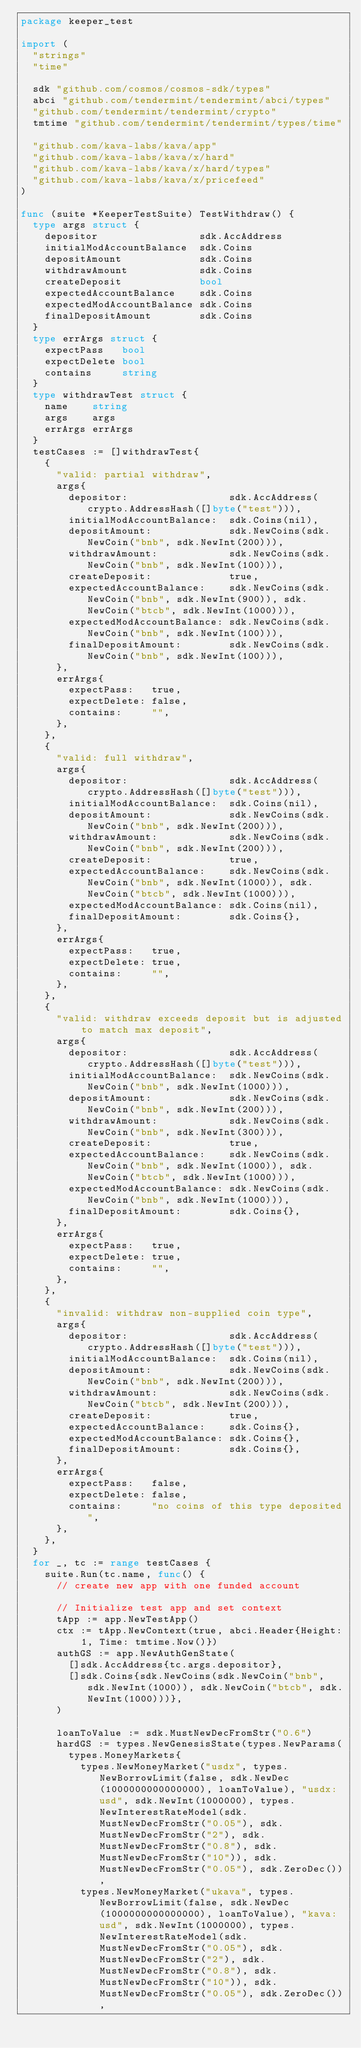Convert code to text. <code><loc_0><loc_0><loc_500><loc_500><_Go_>package keeper_test

import (
	"strings"
	"time"

	sdk "github.com/cosmos/cosmos-sdk/types"
	abci "github.com/tendermint/tendermint/abci/types"
	"github.com/tendermint/tendermint/crypto"
	tmtime "github.com/tendermint/tendermint/types/time"

	"github.com/kava-labs/kava/app"
	"github.com/kava-labs/kava/x/hard"
	"github.com/kava-labs/kava/x/hard/types"
	"github.com/kava-labs/kava/x/pricefeed"
)

func (suite *KeeperTestSuite) TestWithdraw() {
	type args struct {
		depositor                 sdk.AccAddress
		initialModAccountBalance  sdk.Coins
		depositAmount             sdk.Coins
		withdrawAmount            sdk.Coins
		createDeposit             bool
		expectedAccountBalance    sdk.Coins
		expectedModAccountBalance sdk.Coins
		finalDepositAmount        sdk.Coins
	}
	type errArgs struct {
		expectPass   bool
		expectDelete bool
		contains     string
	}
	type withdrawTest struct {
		name    string
		args    args
		errArgs errArgs
	}
	testCases := []withdrawTest{
		{
			"valid: partial withdraw",
			args{
				depositor:                 sdk.AccAddress(crypto.AddressHash([]byte("test"))),
				initialModAccountBalance:  sdk.Coins(nil),
				depositAmount:             sdk.NewCoins(sdk.NewCoin("bnb", sdk.NewInt(200))),
				withdrawAmount:            sdk.NewCoins(sdk.NewCoin("bnb", sdk.NewInt(100))),
				createDeposit:             true,
				expectedAccountBalance:    sdk.NewCoins(sdk.NewCoin("bnb", sdk.NewInt(900)), sdk.NewCoin("btcb", sdk.NewInt(1000))),
				expectedModAccountBalance: sdk.NewCoins(sdk.NewCoin("bnb", sdk.NewInt(100))),
				finalDepositAmount:        sdk.NewCoins(sdk.NewCoin("bnb", sdk.NewInt(100))),
			},
			errArgs{
				expectPass:   true,
				expectDelete: false,
				contains:     "",
			},
		},
		{
			"valid: full withdraw",
			args{
				depositor:                 sdk.AccAddress(crypto.AddressHash([]byte("test"))),
				initialModAccountBalance:  sdk.Coins(nil),
				depositAmount:             sdk.NewCoins(sdk.NewCoin("bnb", sdk.NewInt(200))),
				withdrawAmount:            sdk.NewCoins(sdk.NewCoin("bnb", sdk.NewInt(200))),
				createDeposit:             true,
				expectedAccountBalance:    sdk.NewCoins(sdk.NewCoin("bnb", sdk.NewInt(1000)), sdk.NewCoin("btcb", sdk.NewInt(1000))),
				expectedModAccountBalance: sdk.Coins(nil),
				finalDepositAmount:        sdk.Coins{},
			},
			errArgs{
				expectPass:   true,
				expectDelete: true,
				contains:     "",
			},
		},
		{
			"valid: withdraw exceeds deposit but is adjusted to match max deposit",
			args{
				depositor:                 sdk.AccAddress(crypto.AddressHash([]byte("test"))),
				initialModAccountBalance:  sdk.NewCoins(sdk.NewCoin("bnb", sdk.NewInt(1000))),
				depositAmount:             sdk.NewCoins(sdk.NewCoin("bnb", sdk.NewInt(200))),
				withdrawAmount:            sdk.NewCoins(sdk.NewCoin("bnb", sdk.NewInt(300))),
				createDeposit:             true,
				expectedAccountBalance:    sdk.NewCoins(sdk.NewCoin("bnb", sdk.NewInt(1000)), sdk.NewCoin("btcb", sdk.NewInt(1000))),
				expectedModAccountBalance: sdk.NewCoins(sdk.NewCoin("bnb", sdk.NewInt(1000))),
				finalDepositAmount:        sdk.Coins{},
			},
			errArgs{
				expectPass:   true,
				expectDelete: true,
				contains:     "",
			},
		},
		{
			"invalid: withdraw non-supplied coin type",
			args{
				depositor:                 sdk.AccAddress(crypto.AddressHash([]byte("test"))),
				initialModAccountBalance:  sdk.Coins(nil),
				depositAmount:             sdk.NewCoins(sdk.NewCoin("bnb", sdk.NewInt(200))),
				withdrawAmount:            sdk.NewCoins(sdk.NewCoin("btcb", sdk.NewInt(200))),
				createDeposit:             true,
				expectedAccountBalance:    sdk.Coins{},
				expectedModAccountBalance: sdk.Coins{},
				finalDepositAmount:        sdk.Coins{},
			},
			errArgs{
				expectPass:   false,
				expectDelete: false,
				contains:     "no coins of this type deposited",
			},
		},
	}
	for _, tc := range testCases {
		suite.Run(tc.name, func() {
			// create new app with one funded account

			// Initialize test app and set context
			tApp := app.NewTestApp()
			ctx := tApp.NewContext(true, abci.Header{Height: 1, Time: tmtime.Now()})
			authGS := app.NewAuthGenState(
				[]sdk.AccAddress{tc.args.depositor},
				[]sdk.Coins{sdk.NewCoins(sdk.NewCoin("bnb", sdk.NewInt(1000)), sdk.NewCoin("btcb", sdk.NewInt(1000)))},
			)

			loanToValue := sdk.MustNewDecFromStr("0.6")
			hardGS := types.NewGenesisState(types.NewParams(
				types.MoneyMarkets{
					types.NewMoneyMarket("usdx", types.NewBorrowLimit(false, sdk.NewDec(1000000000000000), loanToValue), "usdx:usd", sdk.NewInt(1000000), types.NewInterestRateModel(sdk.MustNewDecFromStr("0.05"), sdk.MustNewDecFromStr("2"), sdk.MustNewDecFromStr("0.8"), sdk.MustNewDecFromStr("10")), sdk.MustNewDecFromStr("0.05"), sdk.ZeroDec()),
					types.NewMoneyMarket("ukava", types.NewBorrowLimit(false, sdk.NewDec(1000000000000000), loanToValue), "kava:usd", sdk.NewInt(1000000), types.NewInterestRateModel(sdk.MustNewDecFromStr("0.05"), sdk.MustNewDecFromStr("2"), sdk.MustNewDecFromStr("0.8"), sdk.MustNewDecFromStr("10")), sdk.MustNewDecFromStr("0.05"), sdk.ZeroDec()),</code> 